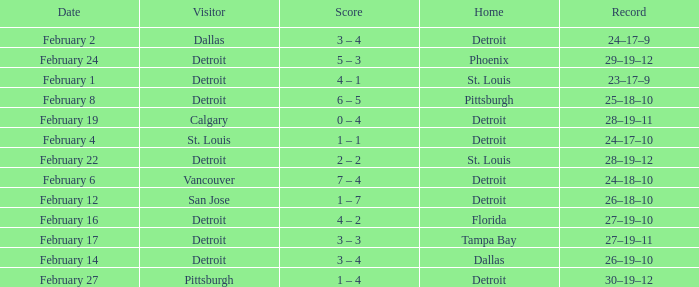What was their record when they were at Pittsburgh? 25–18–10. 